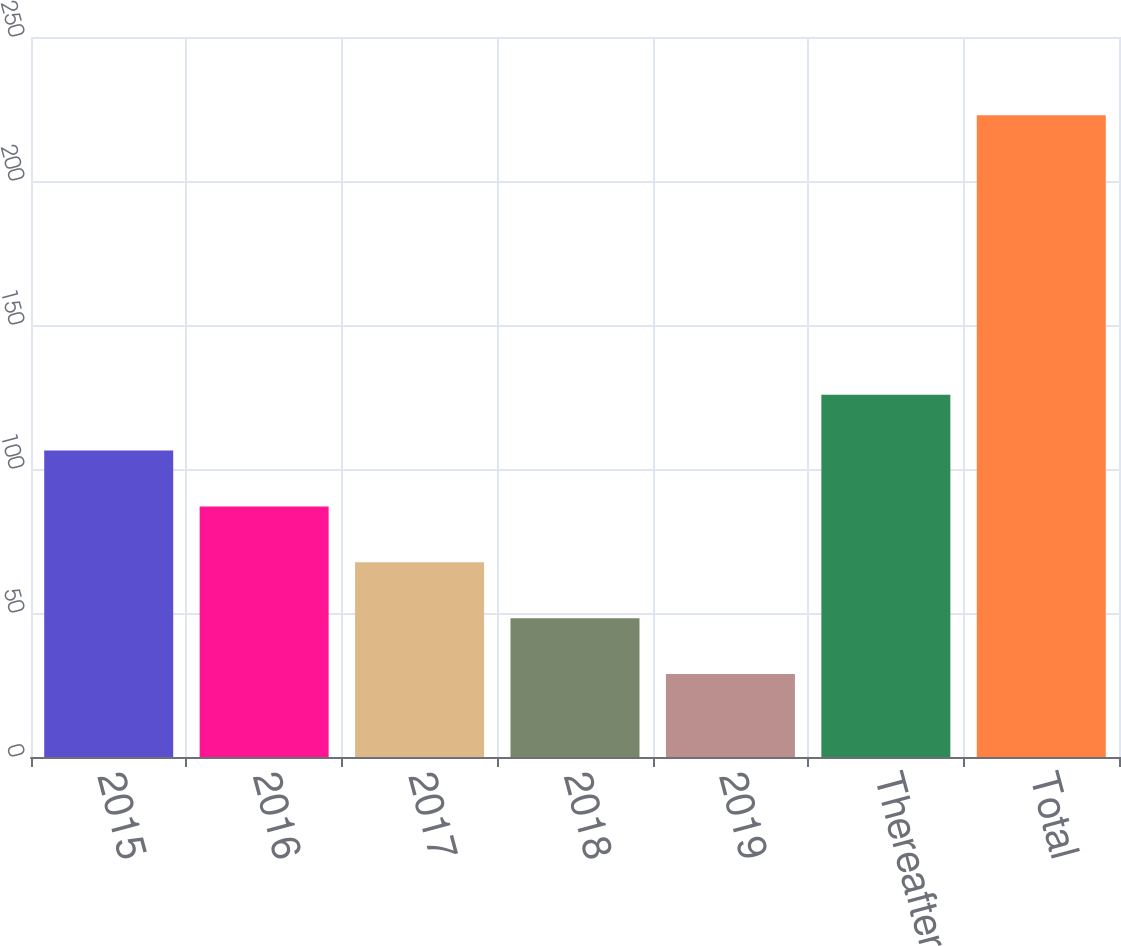Convert chart. <chart><loc_0><loc_0><loc_500><loc_500><bar_chart><fcel>2015<fcel>2016<fcel>2017<fcel>2018<fcel>2019<fcel>Thereafter<fcel>Total<nl><fcel>106.4<fcel>87<fcel>67.6<fcel>48.2<fcel>28.8<fcel>125.8<fcel>222.8<nl></chart> 